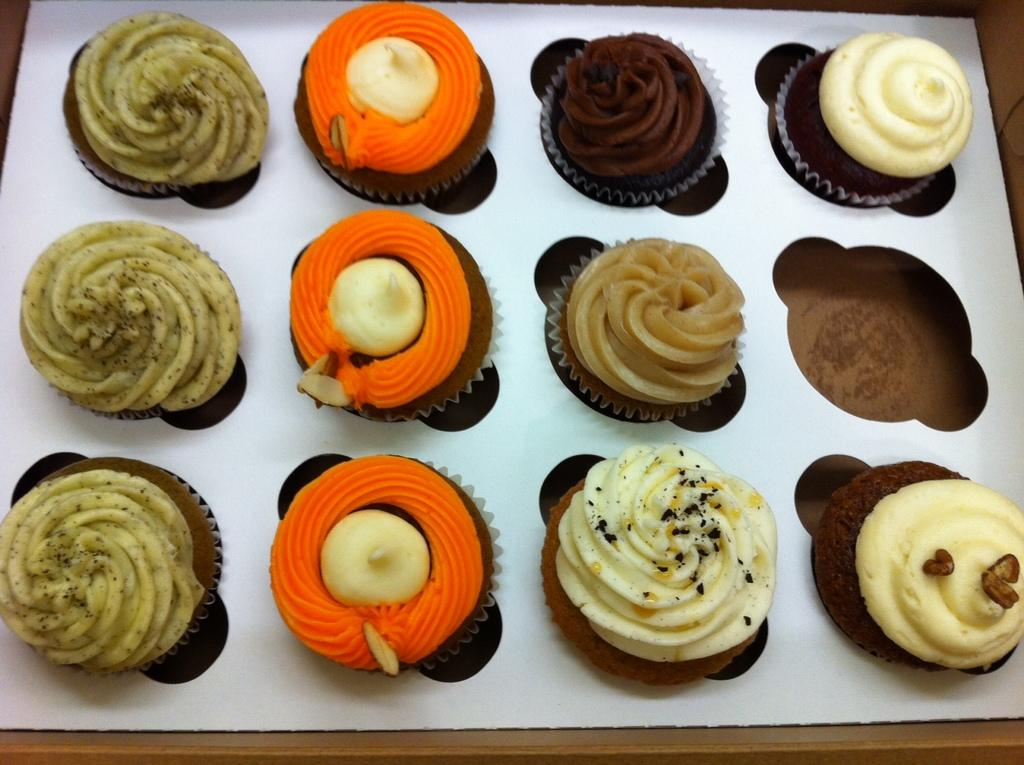What type of food is visible in the image? There are muffins in the image. What is on top of the muffins? The muffins have cream on them. How are the muffins arranged in the image? The muffins are placed on a platform. Can you see any fangs on the muffins in the image? No, there are no fangs present on the muffins in the image. 